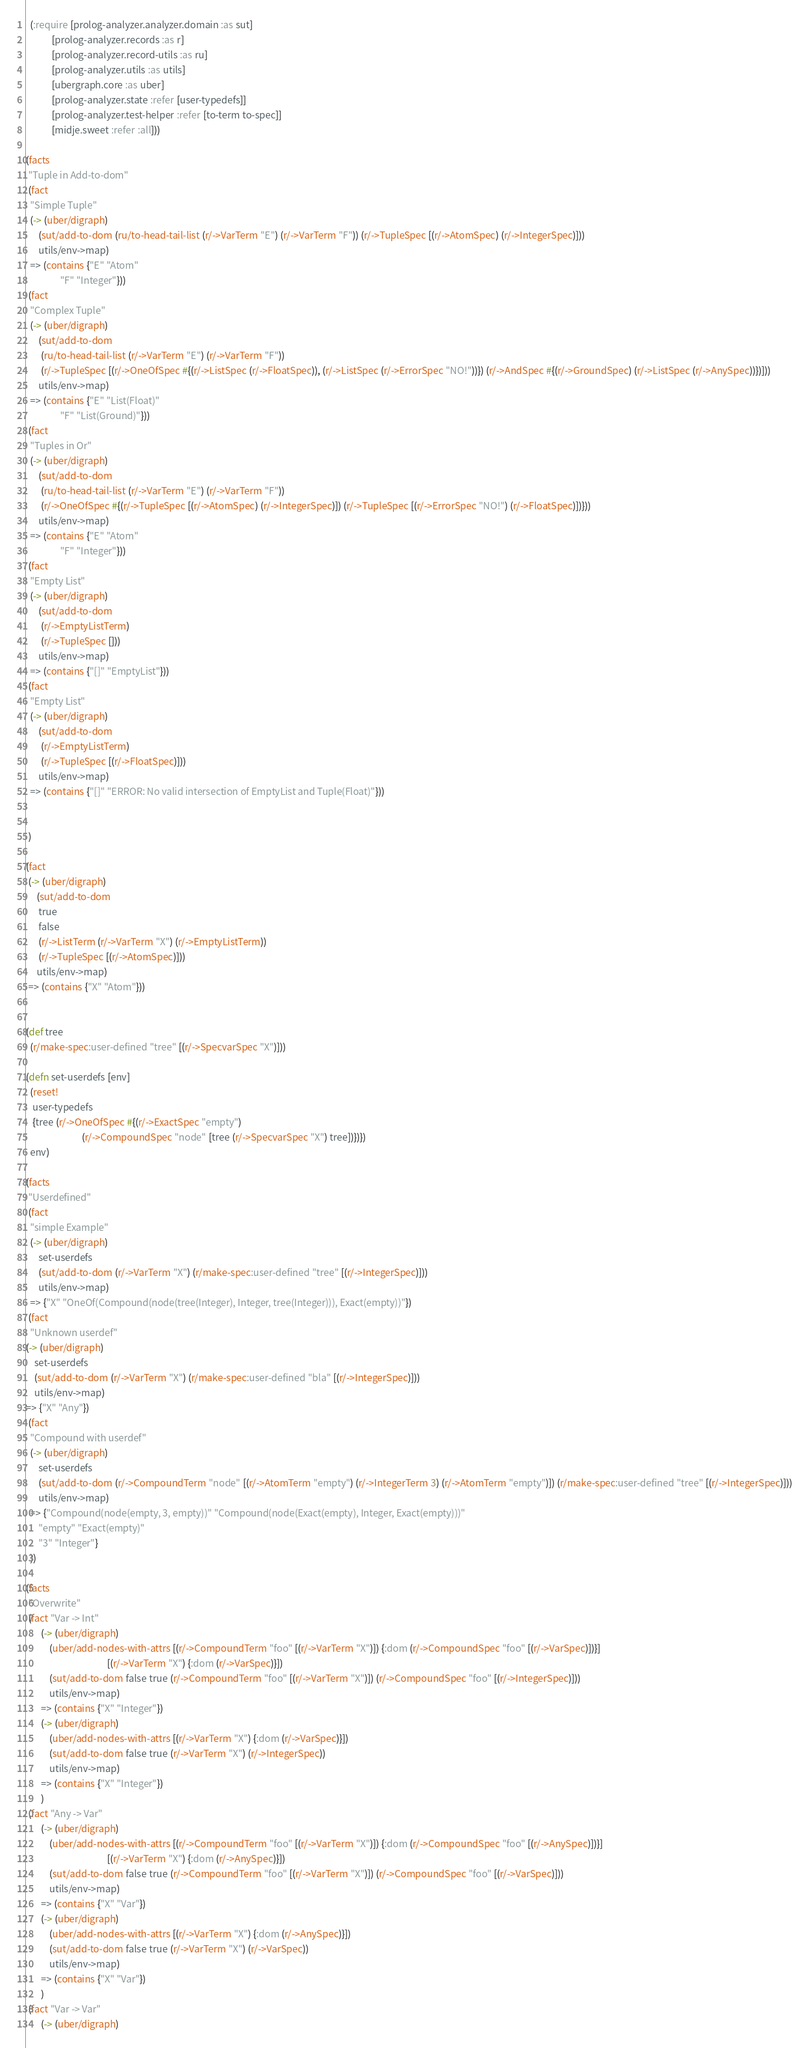Convert code to text. <code><loc_0><loc_0><loc_500><loc_500><_Clojure_>  (:require [prolog-analyzer.analyzer.domain :as sut]
            [prolog-analyzer.records :as r]
            [prolog-analyzer.record-utils :as ru]
            [prolog-analyzer.utils :as utils]
            [ubergraph.core :as uber]
            [prolog-analyzer.state :refer [user-typedefs]]
            [prolog-analyzer.test-helper :refer [to-term to-spec]]
            [midje.sweet :refer :all]))

(facts
 "Tuple in Add-to-dom"
 (fact
  "Simple Tuple"
  (-> (uber/digraph)
      (sut/add-to-dom (ru/to-head-tail-list (r/->VarTerm "E") (r/->VarTerm "F")) (r/->TupleSpec [(r/->AtomSpec) (r/->IntegerSpec)]))
      utils/env->map)
  => (contains {"E" "Atom"
                "F" "Integer"}))
 (fact
  "Complex Tuple"
  (-> (uber/digraph)
      (sut/add-to-dom
       (ru/to-head-tail-list (r/->VarTerm "E") (r/->VarTerm "F"))
       (r/->TupleSpec [(r/->OneOfSpec #{(r/->ListSpec (r/->FloatSpec)), (r/->ListSpec (r/->ErrorSpec "NO!"))}) (r/->AndSpec #{(r/->GroundSpec) (r/->ListSpec (r/->AnySpec))})]))
      utils/env->map)
  => (contains {"E" "List(Float)"
                "F" "List(Ground)"}))
 (fact
  "Tuples in Or"
  (-> (uber/digraph)
      (sut/add-to-dom
       (ru/to-head-tail-list (r/->VarTerm "E") (r/->VarTerm "F"))
       (r/->OneOfSpec #{(r/->TupleSpec [(r/->AtomSpec) (r/->IntegerSpec)]) (r/->TupleSpec [(r/->ErrorSpec "NO!") (r/->FloatSpec)])}))
      utils/env->map)
  => (contains {"E" "Atom"
                "F" "Integer"}))
 (fact
  "Empty List"
  (-> (uber/digraph)
      (sut/add-to-dom
       (r/->EmptyListTerm)
       (r/->TupleSpec []))
      utils/env->map)
  => (contains {"[]" "EmptyList"}))
 (fact
  "Empty List"
  (-> (uber/digraph)
      (sut/add-to-dom
       (r/->EmptyListTerm)
       (r/->TupleSpec [(r/->FloatSpec)]))
      utils/env->map)
  => (contains {"[]" "ERROR: No valid intersection of EmptyList and Tuple(Float)"}))


 )

(fact
 (-> (uber/digraph)
     (sut/add-to-dom
      true
      false
      (r/->ListTerm (r/->VarTerm "X") (r/->EmptyListTerm))
      (r/->TupleSpec [(r/->AtomSpec)]))
     utils/env->map)
 => (contains {"X" "Atom"}))


(def tree
  (r/make-spec:user-defined "tree" [(r/->SpecvarSpec "X")]))

(defn set-userdefs [env]
  (reset!
   user-typedefs
   {tree (r/->OneOfSpec #{(r/->ExactSpec "empty")
                          (r/->CompoundSpec "node" [tree (r/->SpecvarSpec "X") tree])})})
  env)

(facts
 "Userdefined"
 (fact
  "simple Example"
  (-> (uber/digraph)
      set-userdefs
      (sut/add-to-dom (r/->VarTerm "X") (r/make-spec:user-defined "tree" [(r/->IntegerSpec)]))
      utils/env->map)
  => {"X" "OneOf(Compound(node(tree(Integer), Integer, tree(Integer))), Exact(empty))"})
 (fact
  "Unknown userdef"
(-> (uber/digraph)
    set-userdefs
    (sut/add-to-dom (r/->VarTerm "X") (r/make-spec:user-defined "bla" [(r/->IntegerSpec)]))
    utils/env->map)
=> {"X" "Any"})
 (fact
  "Compound with userdef"
  (-> (uber/digraph)
      set-userdefs
      (sut/add-to-dom (r/->CompoundTerm "node" [(r/->AtomTerm "empty") (r/->IntegerTerm 3) (r/->AtomTerm "empty")]) (r/make-spec:user-defined "tree" [(r/->IntegerSpec)]))
      utils/env->map)
  => {"Compound(node(empty, 3, empty))" "Compound(node(Exact(empty), Integer, Exact(empty)))"
      "empty" "Exact(empty)"
      "3" "Integer"}
  ))

(facts
 "Overwrite"
 (fact "Var -> Int"
       (-> (uber/digraph)
           (uber/add-nodes-with-attrs [(r/->CompoundTerm "foo" [(r/->VarTerm "X")]) {:dom (r/->CompoundSpec "foo" [(r/->VarSpec)])}]
                                      [(r/->VarTerm "X") {:dom (r/->VarSpec)}])
           (sut/add-to-dom false true (r/->CompoundTerm "foo" [(r/->VarTerm "X")]) (r/->CompoundSpec "foo" [(r/->IntegerSpec)]))
           utils/env->map)
       => (contains {"X" "Integer"})
       (-> (uber/digraph)
           (uber/add-nodes-with-attrs [(r/->VarTerm "X") {:dom (r/->VarSpec)}])
           (sut/add-to-dom false true (r/->VarTerm "X") (r/->IntegerSpec))
           utils/env->map)
       => (contains {"X" "Integer"})
       )
 (fact "Any -> Var"
       (-> (uber/digraph)
           (uber/add-nodes-with-attrs [(r/->CompoundTerm "foo" [(r/->VarTerm "X")]) {:dom (r/->CompoundSpec "foo" [(r/->AnySpec)])}]
                                      [(r/->VarTerm "X") {:dom (r/->AnySpec)}])
           (sut/add-to-dom false true (r/->CompoundTerm "foo" [(r/->VarTerm "X")]) (r/->CompoundSpec "foo" [(r/->VarSpec)]))
           utils/env->map)
       => (contains {"X" "Var"})
       (-> (uber/digraph)
           (uber/add-nodes-with-attrs [(r/->VarTerm "X") {:dom (r/->AnySpec)}])
           (sut/add-to-dom false true (r/->VarTerm "X") (r/->VarSpec))
           utils/env->map)
       => (contains {"X" "Var"})
       )
 (fact "Var -> Var"
       (-> (uber/digraph)</code> 